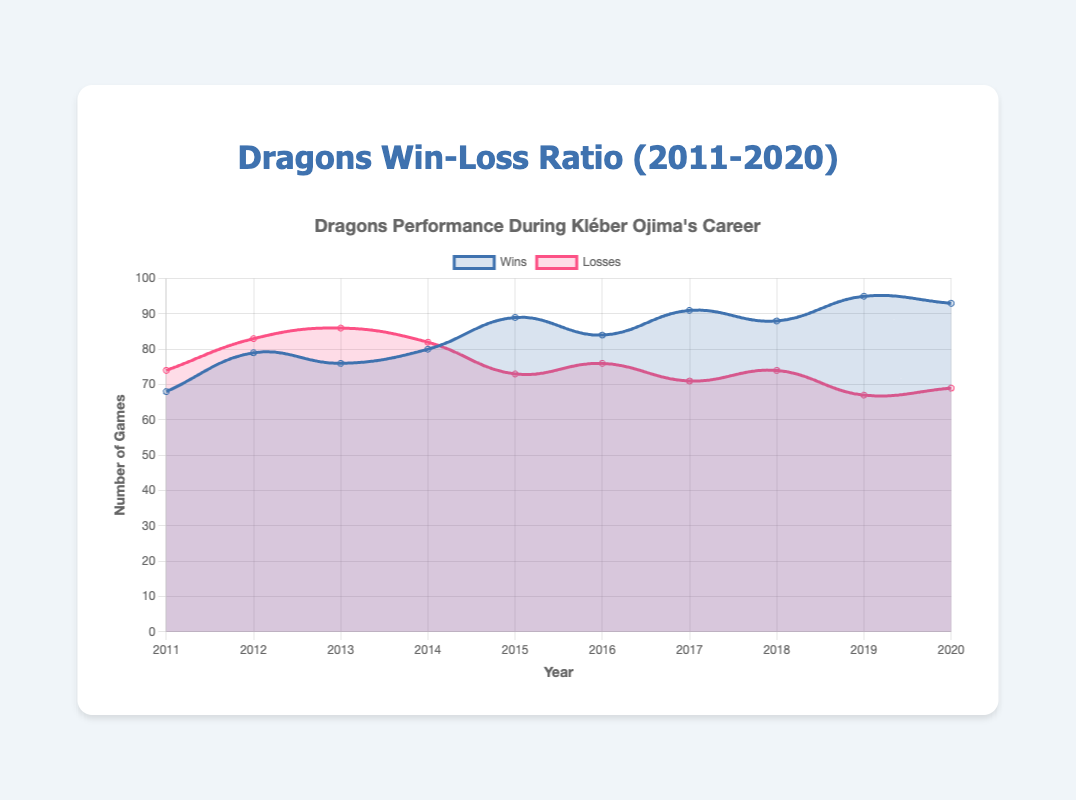Which year had the highest number of wins? The year with the highest number of wins is determined by finding the largest value in the "Wins" dataset, which is 95 in the year 2019.
Answer: 2019 Which year had the lowest number of losses? The year with the lowest number of losses is found by identifying the smallest value in the "Losses" dataset, which is 67 in the year 2019.
Answer: 2019 How many more wins did the Dragons have in 2019 compared to 2011? To calculate the difference in wins between 2019 and 2011, subtract the wins in 2011 from the wins in 2019: 95 - 68 = 27.
Answer: 27 What is the average number of wins across Kléber Ojima's career? To find the average number of wins, sum the wins across all years and divide by the number of years: (68 + 79 + 76 + 80 + 89 + 84 + 91 + 88 + 95 + 93)/10 = 84.3.
Answer: 84.3 In which year did the Dragons have an equal number of wins and losses? By examining the data, we see that there is no year where the number of wins equals the number of losses.
Answer: None What is the trend in the number of losses from 2017 to 2019? Observe the losses from 2017 (71) to 2018 (74) to 2019 (67). There is a decrease from 2018 to 2019 after a small increase from 2017 to 2018.
Answer: Decrease How many total games were played by the Dragons in 2016? The total number of games is the sum of wins and losses: 84 (wins) + 76 (losses) = 160.
Answer: 160 Which two successive years had the greatest increase in wins? To determine the largest increase, calculate the difference in wins for successive years: 2012-2011 (79-68=11), 2013-2012 (76-79=-3), 2014-2013 (80-76=4), 2015-2014 (89-80=9), 2016-2015 (84-89=-5), 2017-2016 (91-84=7), 2018-2017 (88-91=-3), 2019-2018 (95-88=7), 2020-2019 (93-95=-2). The greatest increase is in 2012-2011.
Answer: 2011 to 2012 What is the difference in the total number of games played in 2015 and in 2020? Calculate the total games for each year and then find the difference: 2015 total (89+73=162), 2020 total (93+69=162). Difference: 162 - 162 = 0.
Answer: 0 Which color represents the losses in the plot? The color that represents the losses can be identified visually. The losses are represented by the color red.
Answer: Red 